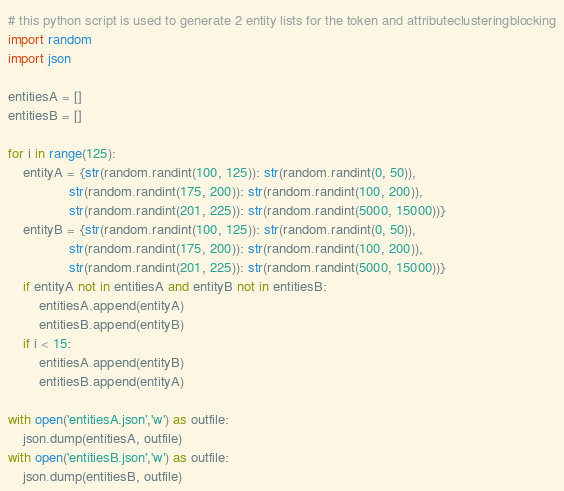Convert code to text. <code><loc_0><loc_0><loc_500><loc_500><_Python_># this python script is used to generate 2 entity lists for the token and attributeclusteringblocking
import random
import json

entitiesA = []
entitiesB = []

for i in range(125):
    entityA = {str(random.randint(100, 125)): str(random.randint(0, 50)), 
                str(random.randint(175, 200)): str(random.randint(100, 200)), 
                str(random.randint(201, 225)): str(random.randint(5000, 15000))}
    entityB = {str(random.randint(100, 125)): str(random.randint(0, 50)), 
                str(random.randint(175, 200)): str(random.randint(100, 200)), 
                str(random.randint(201, 225)): str(random.randint(5000, 15000))}
    if entityA not in entitiesA and entityB not in entitiesB:
        entitiesA.append(entityA)
        entitiesB.append(entityB)
    if i < 15:
        entitiesA.append(entityB)
        entitiesB.append(entityA)

with open('entitiesA.json','w') as outfile:
    json.dump(entitiesA, outfile)
with open('entitiesB.json','w') as outfile:
    json.dump(entitiesB, outfile)</code> 